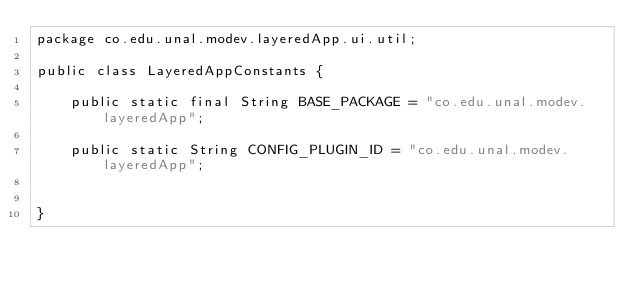Convert code to text. <code><loc_0><loc_0><loc_500><loc_500><_Java_>package co.edu.unal.modev.layeredApp.ui.util;

public class LayeredAppConstants {

	public static final String BASE_PACKAGE = "co.edu.unal.modev.layeredApp";
	
	public static String CONFIG_PLUGIN_ID = "co.edu.unal.modev.layeredApp";

	
}
</code> 